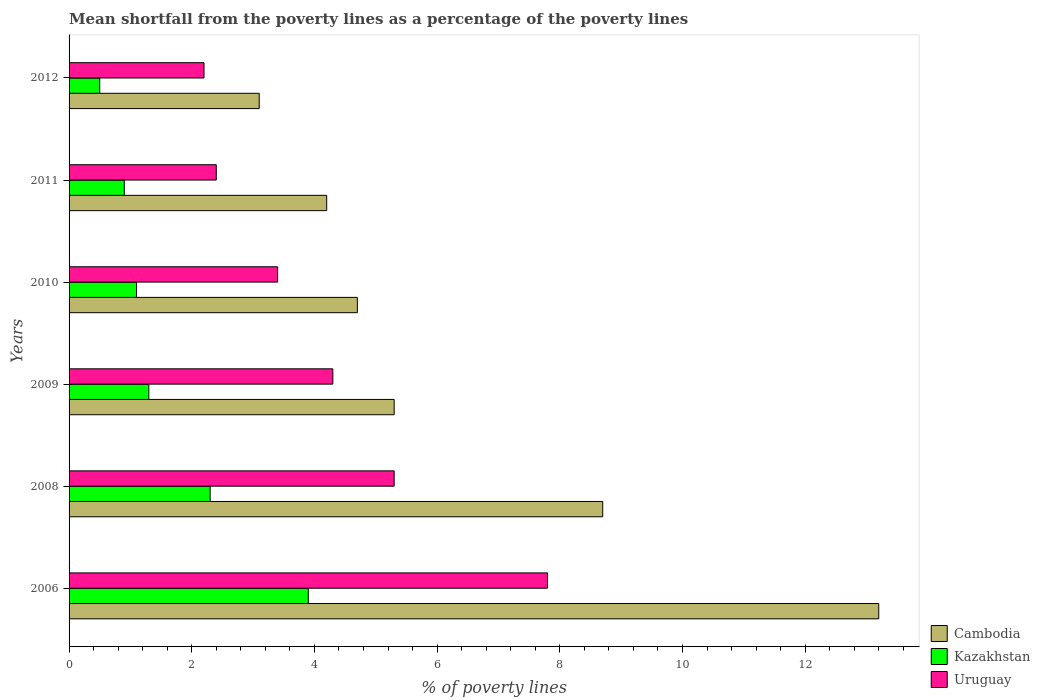How many different coloured bars are there?
Provide a short and direct response. 3. Are the number of bars per tick equal to the number of legend labels?
Give a very brief answer. Yes. How many bars are there on the 2nd tick from the top?
Offer a very short reply. 3. How many bars are there on the 1st tick from the bottom?
Make the answer very short. 3. In which year was the mean shortfall from the poverty lines as a percentage of the poverty lines in Cambodia minimum?
Your answer should be compact. 2012. What is the total mean shortfall from the poverty lines as a percentage of the poverty lines in Kazakhstan in the graph?
Ensure brevity in your answer.  10. What is the difference between the mean shortfall from the poverty lines as a percentage of the poverty lines in Kazakhstan in 2008 and that in 2010?
Offer a very short reply. 1.2. What is the difference between the mean shortfall from the poverty lines as a percentage of the poverty lines in Uruguay in 2006 and the mean shortfall from the poverty lines as a percentage of the poverty lines in Cambodia in 2011?
Offer a terse response. 3.6. What is the average mean shortfall from the poverty lines as a percentage of the poverty lines in Uruguay per year?
Offer a very short reply. 4.23. What is the ratio of the mean shortfall from the poverty lines as a percentage of the poverty lines in Cambodia in 2008 to that in 2010?
Provide a succinct answer. 1.85. Is the mean shortfall from the poverty lines as a percentage of the poverty lines in Kazakhstan in 2008 less than that in 2011?
Your answer should be very brief. No. Is the difference between the mean shortfall from the poverty lines as a percentage of the poverty lines in Cambodia in 2009 and 2011 greater than the difference between the mean shortfall from the poverty lines as a percentage of the poverty lines in Kazakhstan in 2009 and 2011?
Provide a succinct answer. Yes. What is the difference between the highest and the second highest mean shortfall from the poverty lines as a percentage of the poverty lines in Kazakhstan?
Give a very brief answer. 1.6. Is the sum of the mean shortfall from the poverty lines as a percentage of the poverty lines in Cambodia in 2009 and 2011 greater than the maximum mean shortfall from the poverty lines as a percentage of the poverty lines in Kazakhstan across all years?
Provide a succinct answer. Yes. What does the 2nd bar from the top in 2009 represents?
Make the answer very short. Kazakhstan. What does the 3rd bar from the bottom in 2012 represents?
Your answer should be very brief. Uruguay. Is it the case that in every year, the sum of the mean shortfall from the poverty lines as a percentage of the poverty lines in Cambodia and mean shortfall from the poverty lines as a percentage of the poverty lines in Uruguay is greater than the mean shortfall from the poverty lines as a percentage of the poverty lines in Kazakhstan?
Make the answer very short. Yes. How many years are there in the graph?
Your answer should be compact. 6. What is the difference between two consecutive major ticks on the X-axis?
Offer a terse response. 2. Are the values on the major ticks of X-axis written in scientific E-notation?
Give a very brief answer. No. What is the title of the graph?
Offer a terse response. Mean shortfall from the poverty lines as a percentage of the poverty lines. What is the label or title of the X-axis?
Ensure brevity in your answer.  % of poverty lines. What is the label or title of the Y-axis?
Make the answer very short. Years. What is the % of poverty lines in Kazakhstan in 2006?
Make the answer very short. 3.9. What is the % of poverty lines of Uruguay in 2006?
Provide a short and direct response. 7.8. What is the % of poverty lines of Cambodia in 2008?
Offer a terse response. 8.7. What is the % of poverty lines in Kazakhstan in 2008?
Your response must be concise. 2.3. What is the % of poverty lines of Uruguay in 2008?
Your answer should be very brief. 5.3. What is the % of poverty lines in Cambodia in 2009?
Your response must be concise. 5.3. What is the % of poverty lines of Kazakhstan in 2009?
Offer a very short reply. 1.3. What is the % of poverty lines in Uruguay in 2009?
Keep it short and to the point. 4.3. What is the % of poverty lines of Cambodia in 2011?
Offer a terse response. 4.2. What is the % of poverty lines in Uruguay in 2011?
Your answer should be compact. 2.4. Across all years, what is the maximum % of poverty lines in Kazakhstan?
Give a very brief answer. 3.9. Across all years, what is the maximum % of poverty lines in Uruguay?
Provide a succinct answer. 7.8. Across all years, what is the minimum % of poverty lines in Cambodia?
Ensure brevity in your answer.  3.1. Across all years, what is the minimum % of poverty lines in Uruguay?
Your answer should be very brief. 2.2. What is the total % of poverty lines in Cambodia in the graph?
Your answer should be very brief. 39.2. What is the total % of poverty lines in Uruguay in the graph?
Provide a succinct answer. 25.4. What is the difference between the % of poverty lines of Kazakhstan in 2006 and that in 2008?
Ensure brevity in your answer.  1.6. What is the difference between the % of poverty lines in Kazakhstan in 2006 and that in 2009?
Give a very brief answer. 2.6. What is the difference between the % of poverty lines of Uruguay in 2006 and that in 2009?
Offer a terse response. 3.5. What is the difference between the % of poverty lines in Cambodia in 2006 and that in 2010?
Offer a very short reply. 8.5. What is the difference between the % of poverty lines of Kazakhstan in 2006 and that in 2010?
Provide a short and direct response. 2.8. What is the difference between the % of poverty lines in Uruguay in 2006 and that in 2010?
Ensure brevity in your answer.  4.4. What is the difference between the % of poverty lines in Cambodia in 2006 and that in 2012?
Your answer should be compact. 10.1. What is the difference between the % of poverty lines of Cambodia in 2008 and that in 2009?
Ensure brevity in your answer.  3.4. What is the difference between the % of poverty lines in Cambodia in 2008 and that in 2010?
Make the answer very short. 4. What is the difference between the % of poverty lines in Uruguay in 2008 and that in 2010?
Make the answer very short. 1.9. What is the difference between the % of poverty lines of Cambodia in 2009 and that in 2010?
Provide a short and direct response. 0.6. What is the difference between the % of poverty lines in Kazakhstan in 2009 and that in 2010?
Offer a very short reply. 0.2. What is the difference between the % of poverty lines in Uruguay in 2009 and that in 2010?
Provide a succinct answer. 0.9. What is the difference between the % of poverty lines in Kazakhstan in 2009 and that in 2011?
Make the answer very short. 0.4. What is the difference between the % of poverty lines in Uruguay in 2009 and that in 2012?
Keep it short and to the point. 2.1. What is the difference between the % of poverty lines in Cambodia in 2010 and that in 2011?
Keep it short and to the point. 0.5. What is the difference between the % of poverty lines of Kazakhstan in 2010 and that in 2011?
Keep it short and to the point. 0.2. What is the difference between the % of poverty lines in Kazakhstan in 2010 and that in 2012?
Make the answer very short. 0.6. What is the difference between the % of poverty lines in Cambodia in 2011 and that in 2012?
Your response must be concise. 1.1. What is the difference between the % of poverty lines in Cambodia in 2006 and the % of poverty lines in Uruguay in 2008?
Make the answer very short. 7.9. What is the difference between the % of poverty lines of Kazakhstan in 2006 and the % of poverty lines of Uruguay in 2008?
Provide a short and direct response. -1.4. What is the difference between the % of poverty lines in Kazakhstan in 2006 and the % of poverty lines in Uruguay in 2009?
Your answer should be very brief. -0.4. What is the difference between the % of poverty lines in Cambodia in 2006 and the % of poverty lines in Kazakhstan in 2010?
Keep it short and to the point. 12.1. What is the difference between the % of poverty lines in Cambodia in 2006 and the % of poverty lines in Uruguay in 2010?
Your answer should be very brief. 9.8. What is the difference between the % of poverty lines in Cambodia in 2006 and the % of poverty lines in Kazakhstan in 2011?
Provide a succinct answer. 12.3. What is the difference between the % of poverty lines in Cambodia in 2006 and the % of poverty lines in Uruguay in 2012?
Provide a succinct answer. 11. What is the difference between the % of poverty lines in Kazakhstan in 2006 and the % of poverty lines in Uruguay in 2012?
Your answer should be very brief. 1.7. What is the difference between the % of poverty lines of Cambodia in 2008 and the % of poverty lines of Uruguay in 2009?
Your response must be concise. 4.4. What is the difference between the % of poverty lines in Kazakhstan in 2008 and the % of poverty lines in Uruguay in 2009?
Make the answer very short. -2. What is the difference between the % of poverty lines in Cambodia in 2008 and the % of poverty lines in Uruguay in 2010?
Give a very brief answer. 5.3. What is the difference between the % of poverty lines of Kazakhstan in 2008 and the % of poverty lines of Uruguay in 2010?
Provide a succinct answer. -1.1. What is the difference between the % of poverty lines in Cambodia in 2008 and the % of poverty lines in Kazakhstan in 2012?
Provide a short and direct response. 8.2. What is the difference between the % of poverty lines in Cambodia in 2009 and the % of poverty lines in Uruguay in 2010?
Provide a short and direct response. 1.9. What is the difference between the % of poverty lines in Kazakhstan in 2009 and the % of poverty lines in Uruguay in 2010?
Provide a succinct answer. -2.1. What is the difference between the % of poverty lines of Kazakhstan in 2009 and the % of poverty lines of Uruguay in 2011?
Your response must be concise. -1.1. What is the difference between the % of poverty lines of Cambodia in 2009 and the % of poverty lines of Kazakhstan in 2012?
Provide a succinct answer. 4.8. What is the difference between the % of poverty lines of Cambodia in 2009 and the % of poverty lines of Uruguay in 2012?
Keep it short and to the point. 3.1. What is the difference between the % of poverty lines in Cambodia in 2010 and the % of poverty lines in Kazakhstan in 2011?
Give a very brief answer. 3.8. What is the average % of poverty lines in Cambodia per year?
Your response must be concise. 6.53. What is the average % of poverty lines of Uruguay per year?
Make the answer very short. 4.23. In the year 2006, what is the difference between the % of poverty lines of Cambodia and % of poverty lines of Uruguay?
Make the answer very short. 5.4. In the year 2006, what is the difference between the % of poverty lines of Kazakhstan and % of poverty lines of Uruguay?
Your answer should be very brief. -3.9. In the year 2008, what is the difference between the % of poverty lines of Cambodia and % of poverty lines of Kazakhstan?
Your answer should be very brief. 6.4. In the year 2009, what is the difference between the % of poverty lines of Kazakhstan and % of poverty lines of Uruguay?
Your response must be concise. -3. In the year 2010, what is the difference between the % of poverty lines of Kazakhstan and % of poverty lines of Uruguay?
Offer a very short reply. -2.3. In the year 2011, what is the difference between the % of poverty lines in Cambodia and % of poverty lines in Kazakhstan?
Your response must be concise. 3.3. In the year 2012, what is the difference between the % of poverty lines of Cambodia and % of poverty lines of Uruguay?
Ensure brevity in your answer.  0.9. What is the ratio of the % of poverty lines of Cambodia in 2006 to that in 2008?
Offer a terse response. 1.52. What is the ratio of the % of poverty lines of Kazakhstan in 2006 to that in 2008?
Make the answer very short. 1.7. What is the ratio of the % of poverty lines in Uruguay in 2006 to that in 2008?
Ensure brevity in your answer.  1.47. What is the ratio of the % of poverty lines of Cambodia in 2006 to that in 2009?
Your answer should be compact. 2.49. What is the ratio of the % of poverty lines in Uruguay in 2006 to that in 2009?
Offer a very short reply. 1.81. What is the ratio of the % of poverty lines of Cambodia in 2006 to that in 2010?
Provide a succinct answer. 2.81. What is the ratio of the % of poverty lines of Kazakhstan in 2006 to that in 2010?
Your response must be concise. 3.55. What is the ratio of the % of poverty lines of Uruguay in 2006 to that in 2010?
Your answer should be very brief. 2.29. What is the ratio of the % of poverty lines of Cambodia in 2006 to that in 2011?
Ensure brevity in your answer.  3.14. What is the ratio of the % of poverty lines of Kazakhstan in 2006 to that in 2011?
Give a very brief answer. 4.33. What is the ratio of the % of poverty lines in Cambodia in 2006 to that in 2012?
Your answer should be very brief. 4.26. What is the ratio of the % of poverty lines of Uruguay in 2006 to that in 2012?
Make the answer very short. 3.55. What is the ratio of the % of poverty lines of Cambodia in 2008 to that in 2009?
Keep it short and to the point. 1.64. What is the ratio of the % of poverty lines in Kazakhstan in 2008 to that in 2009?
Your answer should be compact. 1.77. What is the ratio of the % of poverty lines in Uruguay in 2008 to that in 2009?
Keep it short and to the point. 1.23. What is the ratio of the % of poverty lines of Cambodia in 2008 to that in 2010?
Your response must be concise. 1.85. What is the ratio of the % of poverty lines in Kazakhstan in 2008 to that in 2010?
Your answer should be compact. 2.09. What is the ratio of the % of poverty lines of Uruguay in 2008 to that in 2010?
Ensure brevity in your answer.  1.56. What is the ratio of the % of poverty lines in Cambodia in 2008 to that in 2011?
Your answer should be compact. 2.07. What is the ratio of the % of poverty lines in Kazakhstan in 2008 to that in 2011?
Make the answer very short. 2.56. What is the ratio of the % of poverty lines in Uruguay in 2008 to that in 2011?
Give a very brief answer. 2.21. What is the ratio of the % of poverty lines of Cambodia in 2008 to that in 2012?
Your answer should be very brief. 2.81. What is the ratio of the % of poverty lines in Kazakhstan in 2008 to that in 2012?
Provide a succinct answer. 4.6. What is the ratio of the % of poverty lines in Uruguay in 2008 to that in 2012?
Give a very brief answer. 2.41. What is the ratio of the % of poverty lines in Cambodia in 2009 to that in 2010?
Offer a terse response. 1.13. What is the ratio of the % of poverty lines of Kazakhstan in 2009 to that in 2010?
Offer a terse response. 1.18. What is the ratio of the % of poverty lines in Uruguay in 2009 to that in 2010?
Give a very brief answer. 1.26. What is the ratio of the % of poverty lines in Cambodia in 2009 to that in 2011?
Offer a very short reply. 1.26. What is the ratio of the % of poverty lines in Kazakhstan in 2009 to that in 2011?
Give a very brief answer. 1.44. What is the ratio of the % of poverty lines in Uruguay in 2009 to that in 2011?
Provide a succinct answer. 1.79. What is the ratio of the % of poverty lines in Cambodia in 2009 to that in 2012?
Your answer should be very brief. 1.71. What is the ratio of the % of poverty lines of Uruguay in 2009 to that in 2012?
Offer a very short reply. 1.95. What is the ratio of the % of poverty lines of Cambodia in 2010 to that in 2011?
Your answer should be compact. 1.12. What is the ratio of the % of poverty lines in Kazakhstan in 2010 to that in 2011?
Your answer should be compact. 1.22. What is the ratio of the % of poverty lines in Uruguay in 2010 to that in 2011?
Your response must be concise. 1.42. What is the ratio of the % of poverty lines in Cambodia in 2010 to that in 2012?
Give a very brief answer. 1.52. What is the ratio of the % of poverty lines in Uruguay in 2010 to that in 2012?
Offer a terse response. 1.55. What is the ratio of the % of poverty lines in Cambodia in 2011 to that in 2012?
Provide a succinct answer. 1.35. What is the ratio of the % of poverty lines in Kazakhstan in 2011 to that in 2012?
Give a very brief answer. 1.8. What is the ratio of the % of poverty lines of Uruguay in 2011 to that in 2012?
Provide a short and direct response. 1.09. What is the difference between the highest and the second highest % of poverty lines in Cambodia?
Offer a terse response. 4.5. What is the difference between the highest and the second highest % of poverty lines in Kazakhstan?
Your response must be concise. 1.6. What is the difference between the highest and the lowest % of poverty lines of Cambodia?
Provide a succinct answer. 10.1. What is the difference between the highest and the lowest % of poverty lines in Kazakhstan?
Offer a terse response. 3.4. What is the difference between the highest and the lowest % of poverty lines of Uruguay?
Give a very brief answer. 5.6. 